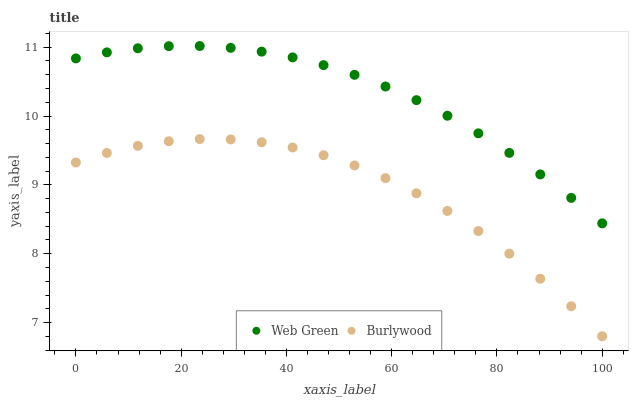Does Burlywood have the minimum area under the curve?
Answer yes or no. Yes. Does Web Green have the maximum area under the curve?
Answer yes or no. Yes. Does Web Green have the minimum area under the curve?
Answer yes or no. No. Is Web Green the smoothest?
Answer yes or no. Yes. Is Burlywood the roughest?
Answer yes or no. Yes. Is Web Green the roughest?
Answer yes or no. No. Does Burlywood have the lowest value?
Answer yes or no. Yes. Does Web Green have the lowest value?
Answer yes or no. No. Does Web Green have the highest value?
Answer yes or no. Yes. Is Burlywood less than Web Green?
Answer yes or no. Yes. Is Web Green greater than Burlywood?
Answer yes or no. Yes. Does Burlywood intersect Web Green?
Answer yes or no. No. 